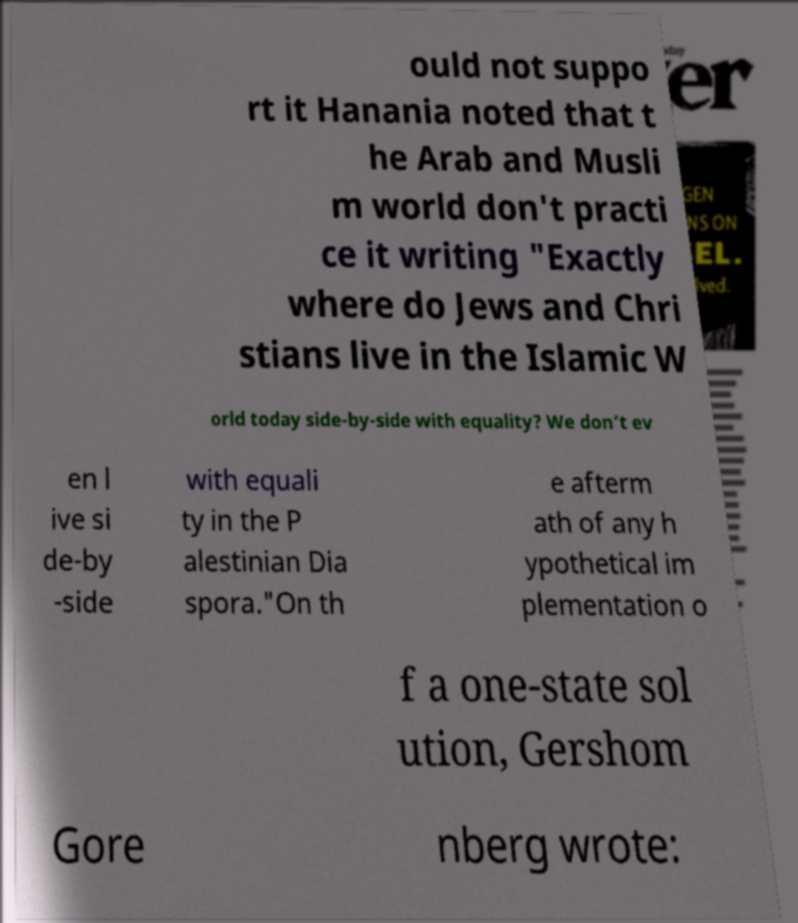Please identify and transcribe the text found in this image. ould not suppo rt it Hanania noted that t he Arab and Musli m world don't practi ce it writing "Exactly where do Jews and Chri stians live in the Islamic W orld today side-by-side with equality? We don’t ev en l ive si de-by -side with equali ty in the P alestinian Dia spora."On th e afterm ath of any h ypothetical im plementation o f a one-state sol ution, Gershom Gore nberg wrote: 